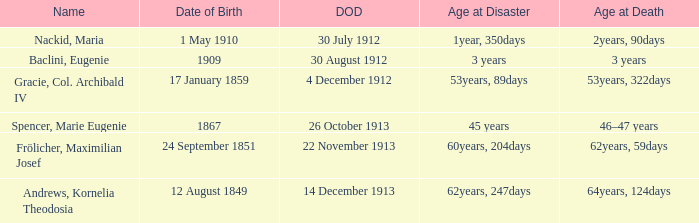What is the name of the person born in 1909? Baclini, Eugenie. 